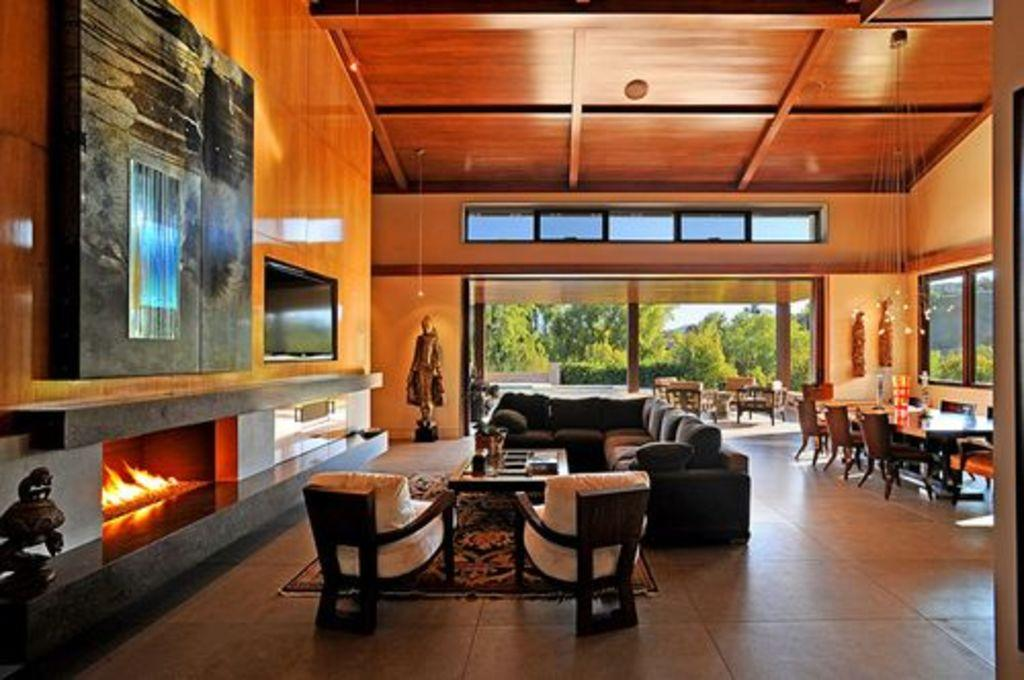What type of furniture can be seen in the image? There are sofas, chairs, and tables in the image. What is located on the left side of the image? There is a television and a statue on the left side of the image. What objects are on the table in the image? There are glasses on a table in the image. What type of bird is sitting on the cake in the image? There is no bird or cake present in the image. What type of bun is visible on the table in the image? There are no buns visible on the table in the image. 